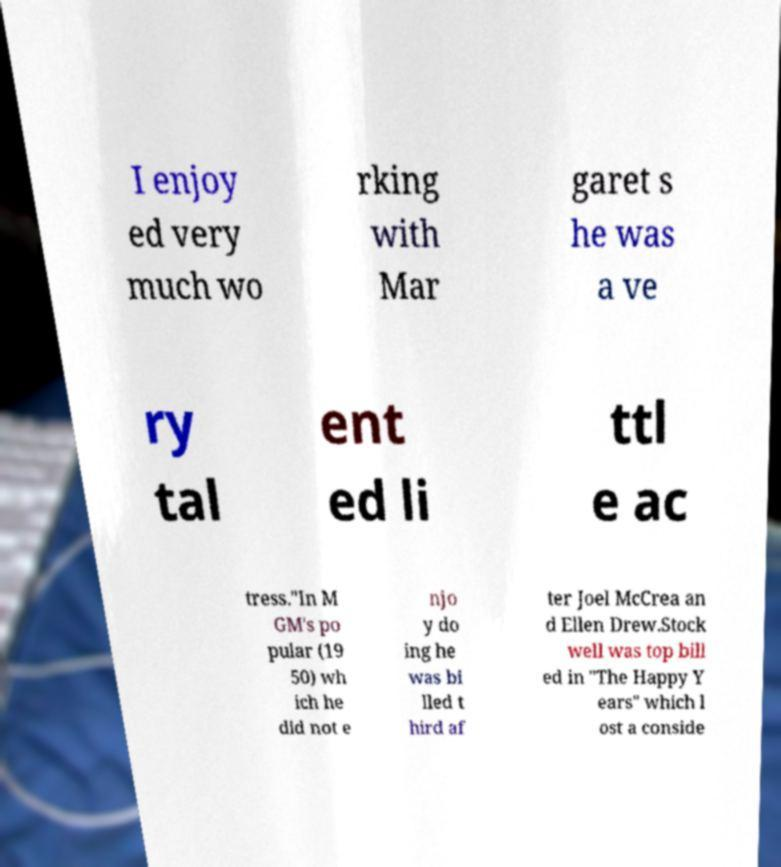For documentation purposes, I need the text within this image transcribed. Could you provide that? I enjoy ed very much wo rking with Mar garet s he was a ve ry tal ent ed li ttl e ac tress."In M GM's po pular (19 50) wh ich he did not e njo y do ing he was bi lled t hird af ter Joel McCrea an d Ellen Drew.Stock well was top bill ed in "The Happy Y ears" which l ost a conside 